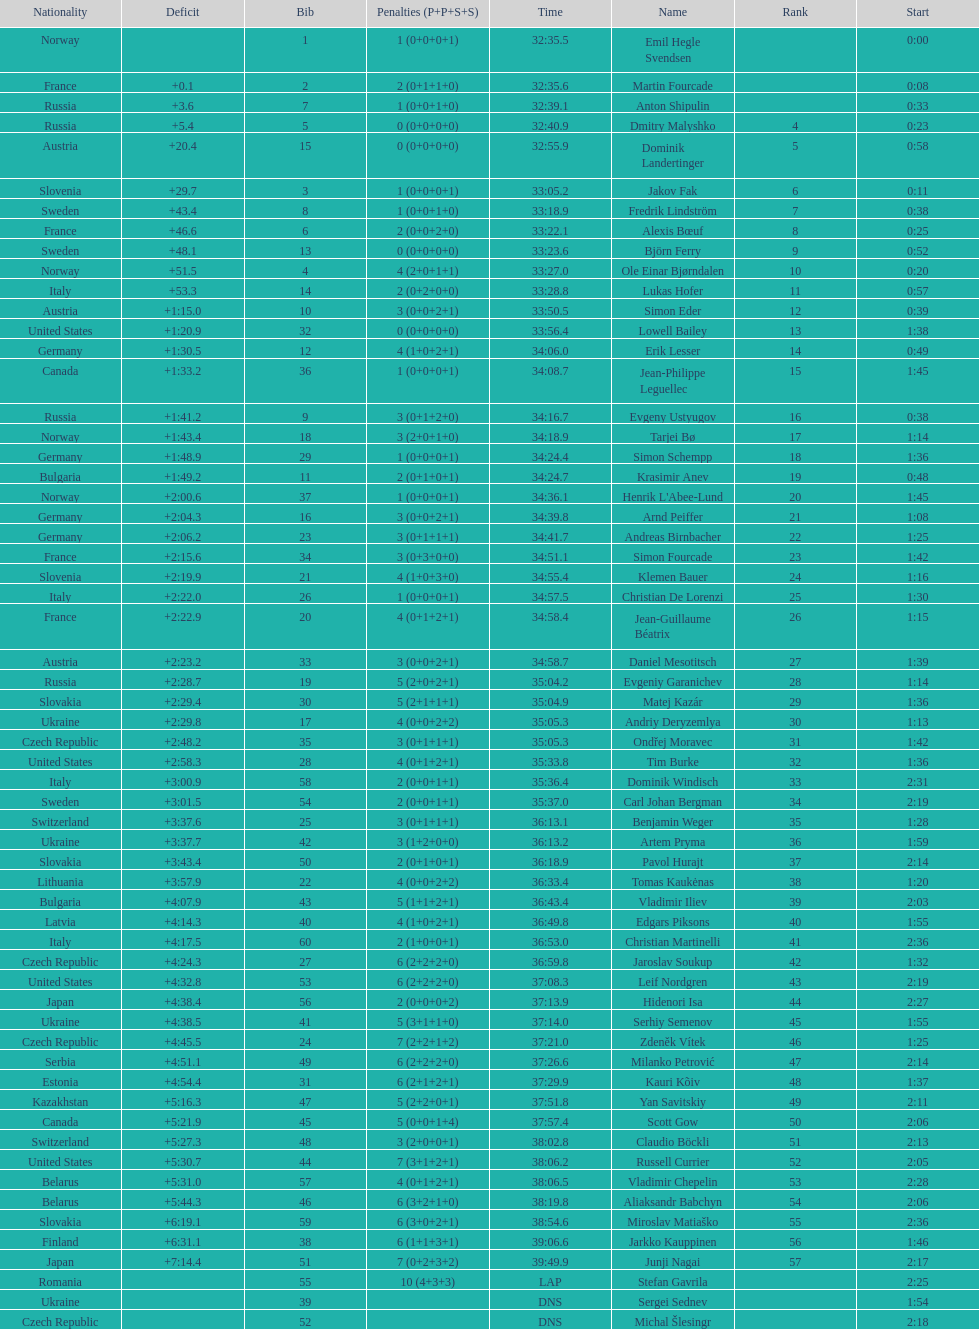Other than burke, name an athlete from the us. Leif Nordgren. 